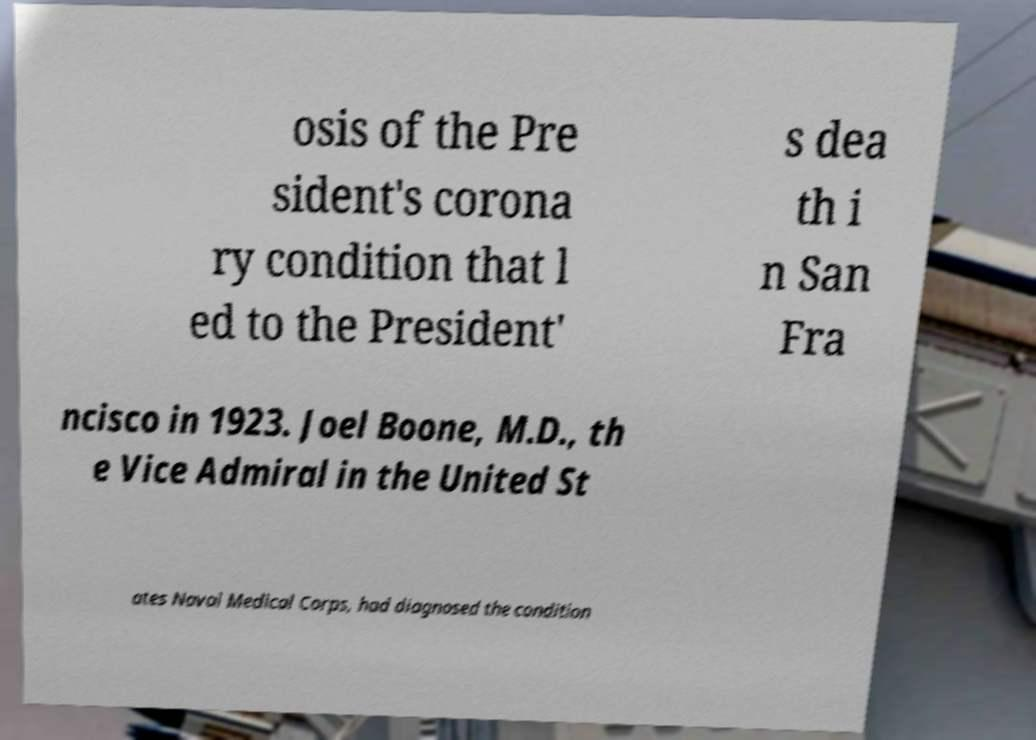There's text embedded in this image that I need extracted. Can you transcribe it verbatim? osis of the Pre sident's corona ry condition that l ed to the President' s dea th i n San Fra ncisco in 1923. Joel Boone, M.D., th e Vice Admiral in the United St ates Naval Medical Corps, had diagnosed the condition 